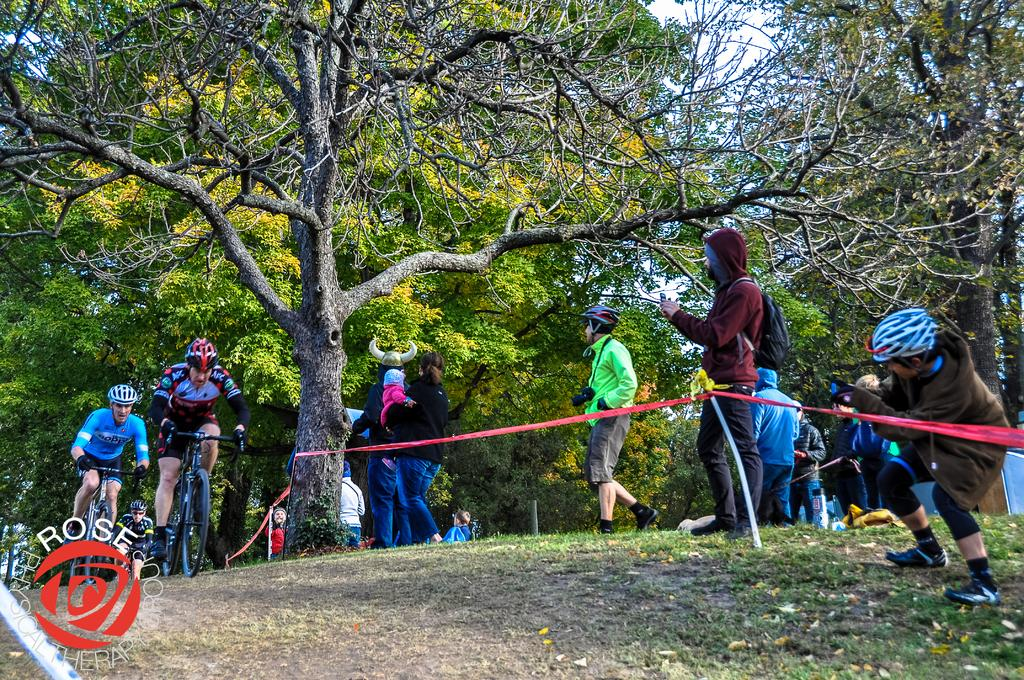How many persons are in the image? There are persons standing in the image. What are two of the persons doing in the image? Two persons are riding bicycles in the image. What safety precaution are the bicycle riders taking? The bicycle riders are wearing helmets. What type of natural environment is visible in the image? Trees, grass, and the sky are visible in the image. What object is one person holding in the image? One person is holding a mobile phone. What color is the paint being used by the person whistling in the image? There is no person whistling or using paint in the image. What type of whistle is being used by the person painting in the image? There is no person painting or using a whistle in the image. 